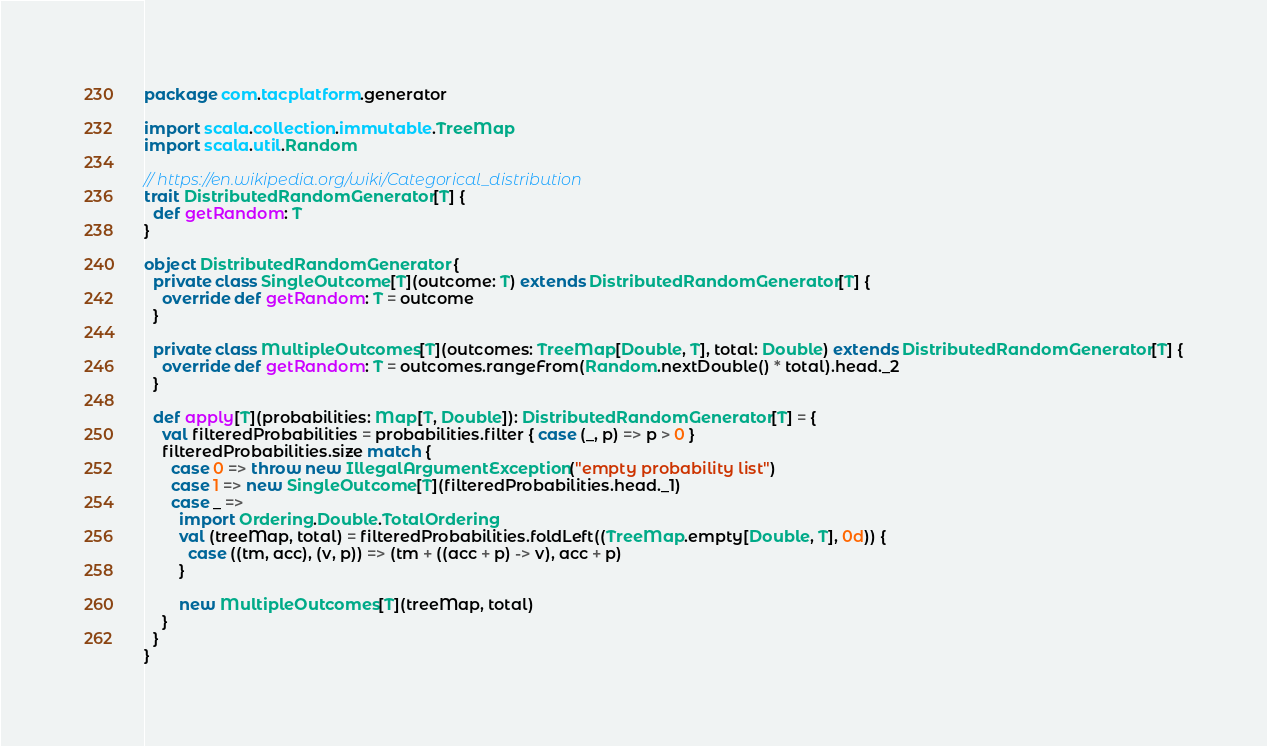<code> <loc_0><loc_0><loc_500><loc_500><_Scala_>package com.tacplatform.generator

import scala.collection.immutable.TreeMap
import scala.util.Random

// https://en.wikipedia.org/wiki/Categorical_distribution
trait DistributedRandomGenerator[T] {
  def getRandom: T
}

object DistributedRandomGenerator {
  private class SingleOutcome[T](outcome: T) extends DistributedRandomGenerator[T] {
    override def getRandom: T = outcome
  }

  private class MultipleOutcomes[T](outcomes: TreeMap[Double, T], total: Double) extends DistributedRandomGenerator[T] {
    override def getRandom: T = outcomes.rangeFrom(Random.nextDouble() * total).head._2
  }

  def apply[T](probabilities: Map[T, Double]): DistributedRandomGenerator[T] = {
    val filteredProbabilities = probabilities.filter { case (_, p) => p > 0 }
    filteredProbabilities.size match {
      case 0 => throw new IllegalArgumentException("empty probability list")
      case 1 => new SingleOutcome[T](filteredProbabilities.head._1)
      case _ =>
        import Ordering.Double.TotalOrdering
        val (treeMap, total) = filteredProbabilities.foldLeft((TreeMap.empty[Double, T], 0d)) {
          case ((tm, acc), (v, p)) => (tm + ((acc + p) -> v), acc + p)
        }

        new MultipleOutcomes[T](treeMap, total)
    }
  }
}
</code> 